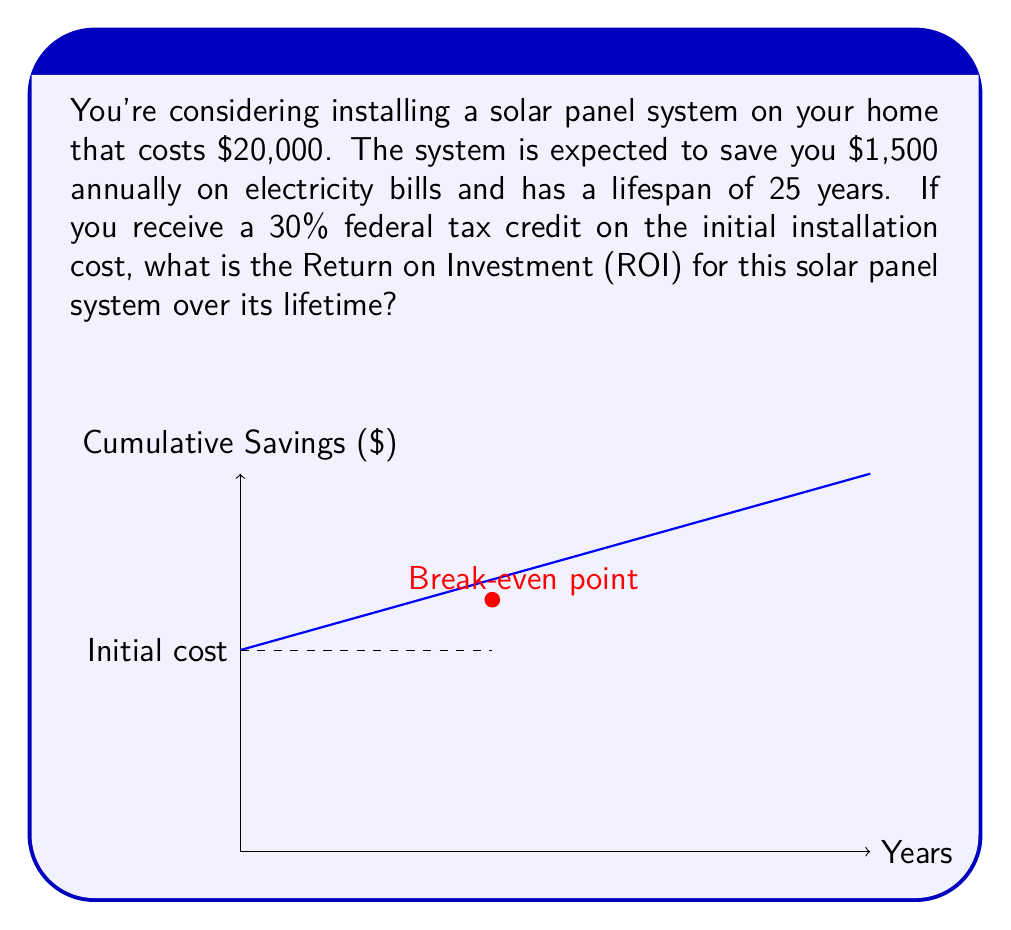Can you answer this question? Let's break this down step-by-step:

1) First, calculate the actual cost after the tax credit:
   Initial cost = $20,000
   Tax credit = 30% of $20,000 = $6,000
   Actual cost = $20,000 - $6,000 = $14,000

2) Calculate total savings over the system's lifetime:
   Annual savings = $1,500
   Lifespan = 25 years
   Total savings = $1,500 * 25 = $37,500

3) Calculate net profit:
   Net profit = Total savings - Actual cost
   Net profit = $37,500 - $14,000 = $23,500

4) Calculate ROI:
   ROI is typically expressed as a percentage and calculated as:
   
   $$ ROI = \frac{\text{Net Profit}}{\text{Cost of Investment}} \times 100\% $$

   $$ ROI = \frac{23,500}{14,000} \times 100\% \approx 167.86\% $$

Therefore, the ROI for this solar panel system over its lifetime is approximately 167.86%.
Answer: 167.86% 